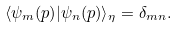Convert formula to latex. <formula><loc_0><loc_0><loc_500><loc_500>\langle \psi _ { m } ( p ) | \psi _ { n } ( p ) \rangle _ { \eta } = \delta _ { m n } .</formula> 